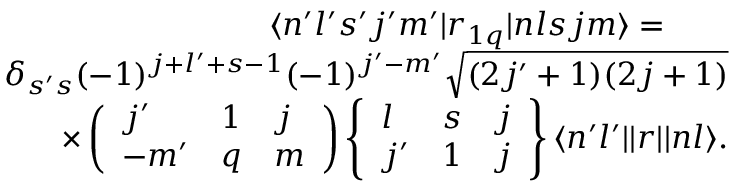Convert formula to latex. <formula><loc_0><loc_0><loc_500><loc_500>\begin{array} { r } { \langle n ^ { \prime } l ^ { \prime } s ^ { \prime } j ^ { \prime } m ^ { \prime } | r _ { 1 q } | n l s j m \rangle = \quad } \\ { \delta _ { s ^ { \prime } s } ( - 1 ) ^ { j + l ^ { \prime } + s - 1 } ( - 1 ) ^ { j ^ { \prime } - m ^ { \prime } } \sqrt { ( 2 j ^ { \prime } + 1 ) ( 2 j + 1 ) } } \\ { \times \left ( \begin{array} { l l l } { j ^ { \prime } } & { 1 } & { j } \\ { - m ^ { \prime } } & { q } & { m } \end{array} \right ) \left \{ \begin{array} { l l l } { l } & { s } & { j } \\ { j ^ { \prime } } & { 1 } & { j } \end{array} \right \} \langle n ^ { \prime } l ^ { \prime } | | r | | n l \rangle . } \end{array}</formula> 